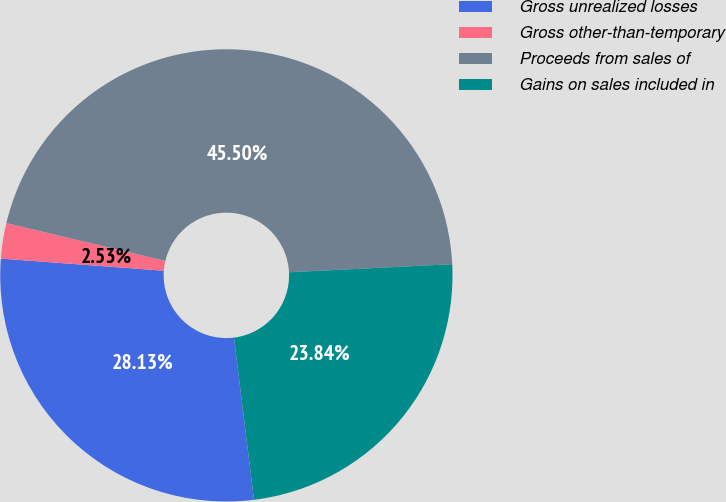Convert chart to OTSL. <chart><loc_0><loc_0><loc_500><loc_500><pie_chart><fcel>Gross unrealized losses<fcel>Gross other-than-temporary<fcel>Proceeds from sales of<fcel>Gains on sales included in<nl><fcel>28.13%<fcel>2.53%<fcel>45.5%<fcel>23.84%<nl></chart> 